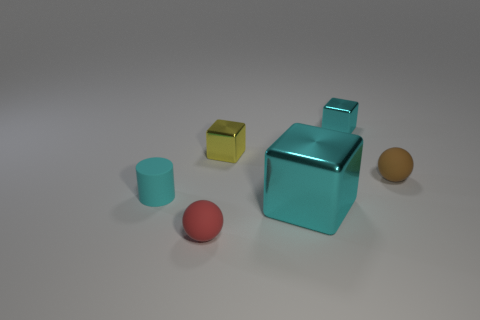What number of other objects are there of the same color as the tiny rubber cylinder?
Make the answer very short. 2. How big is the brown rubber thing?
Provide a succinct answer. Small. Are there any small brown matte spheres?
Ensure brevity in your answer.  Yes. Are there more cyan rubber objects that are to the left of the tiny brown rubber ball than large cyan blocks that are behind the yellow object?
Ensure brevity in your answer.  Yes. The object that is both on the left side of the big cyan metallic cube and behind the cyan cylinder is made of what material?
Ensure brevity in your answer.  Metal. Is the tiny brown object the same shape as the big cyan object?
Offer a very short reply. No. There is a small brown matte object; how many cyan matte cylinders are in front of it?
Offer a terse response. 1. Is the size of the rubber thing that is in front of the cyan rubber cylinder the same as the small brown matte ball?
Keep it short and to the point. Yes. What is the color of the large thing that is the same shape as the tiny cyan shiny thing?
Make the answer very short. Cyan. Is there any other thing that has the same shape as the small cyan rubber object?
Offer a terse response. No. 